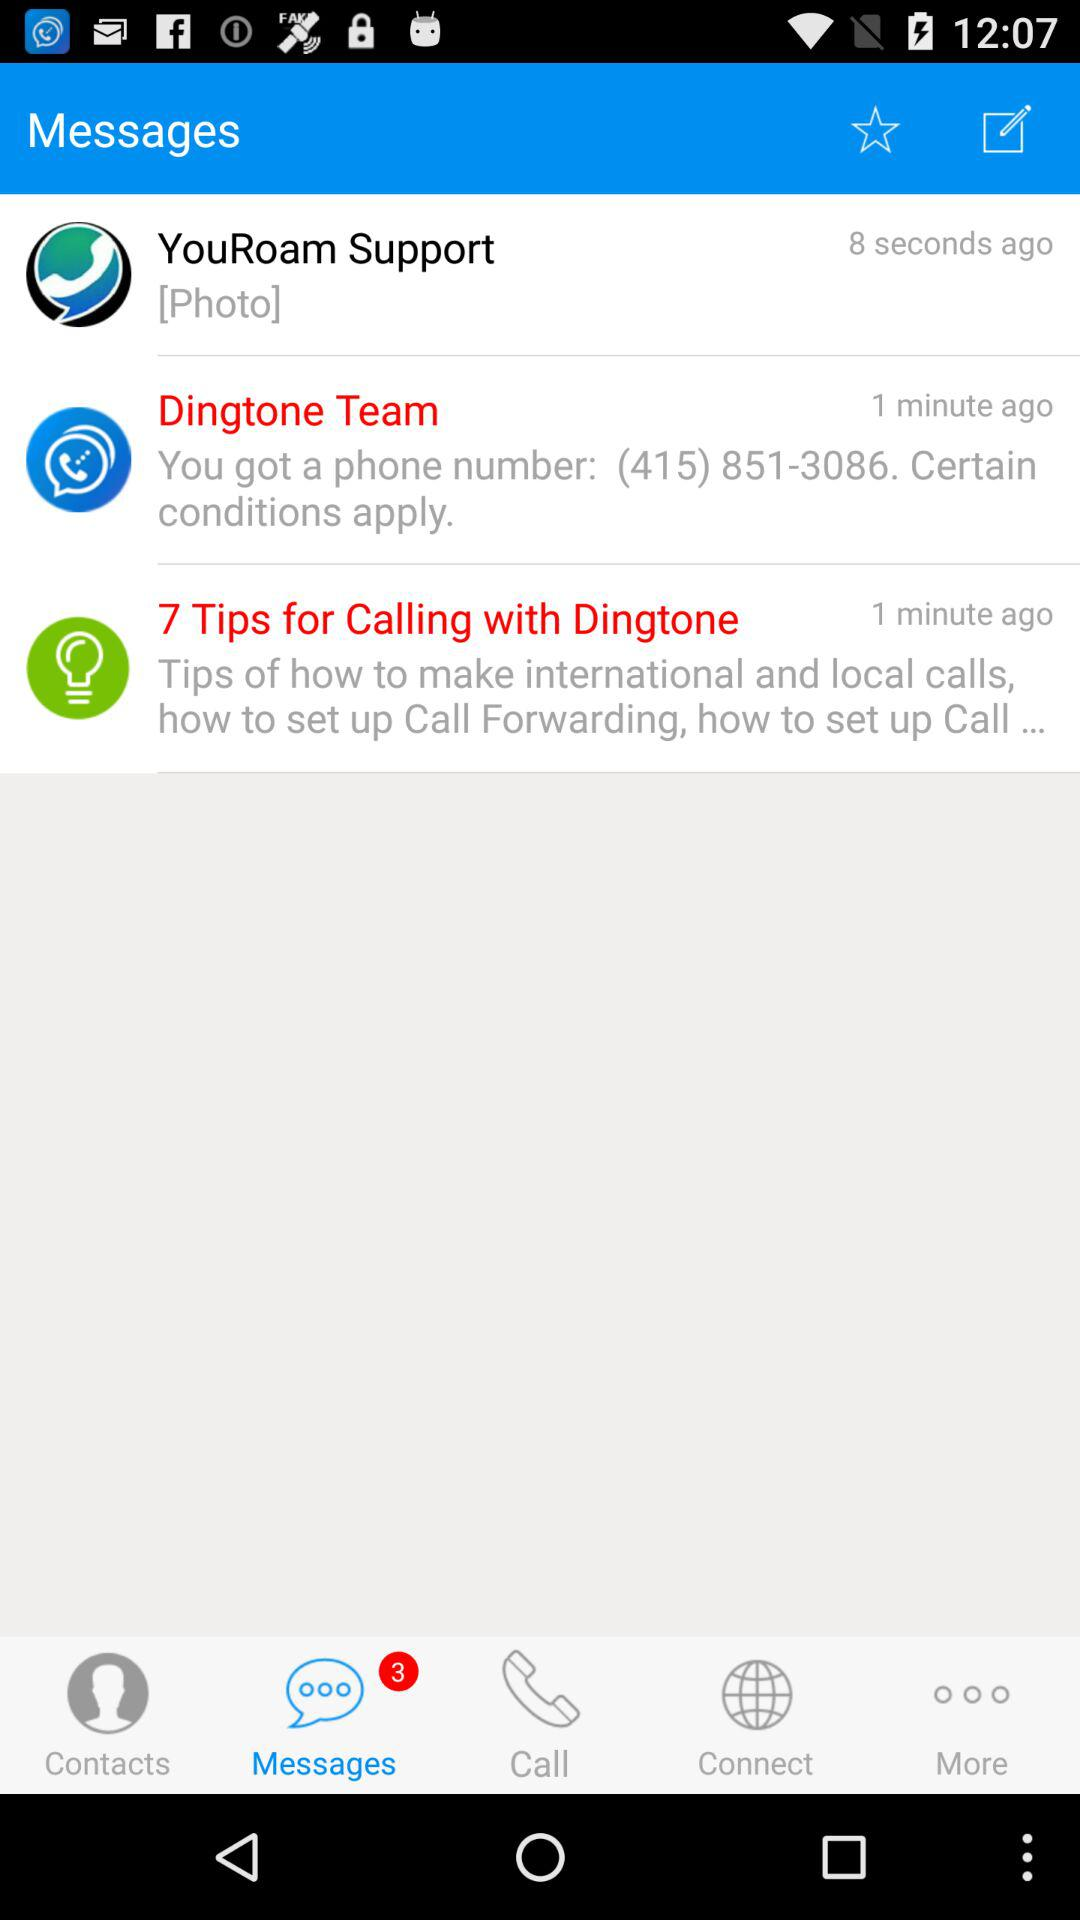Who sent the message related to the phone number? The message was sent by "Dingtone Team". 